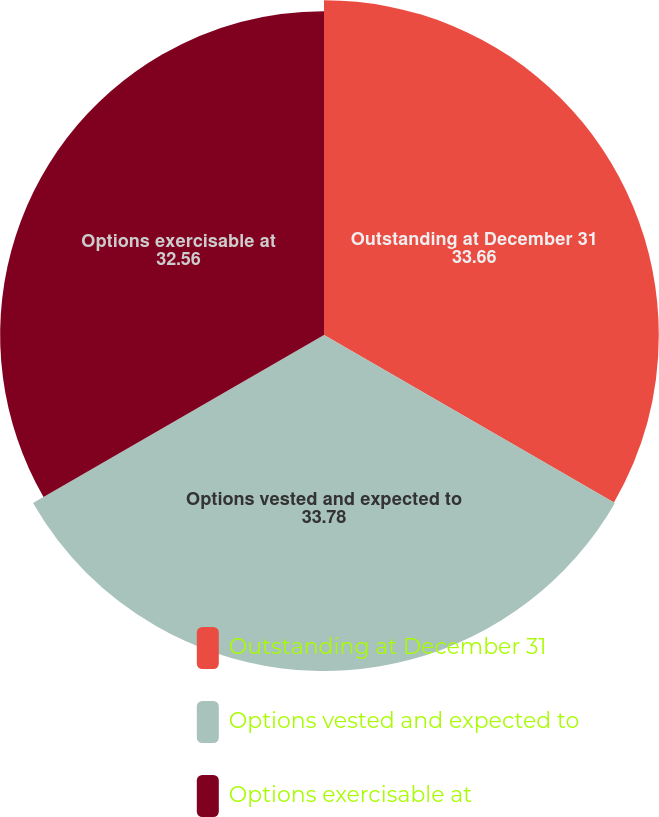Convert chart. <chart><loc_0><loc_0><loc_500><loc_500><pie_chart><fcel>Outstanding at December 31<fcel>Options vested and expected to<fcel>Options exercisable at<nl><fcel>33.66%<fcel>33.78%<fcel>32.56%<nl></chart> 